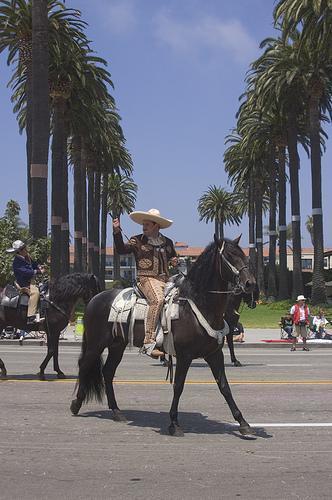How many horses are there?
Give a very brief answer. 2. How many giraffes are in the picture?
Give a very brief answer. 0. 